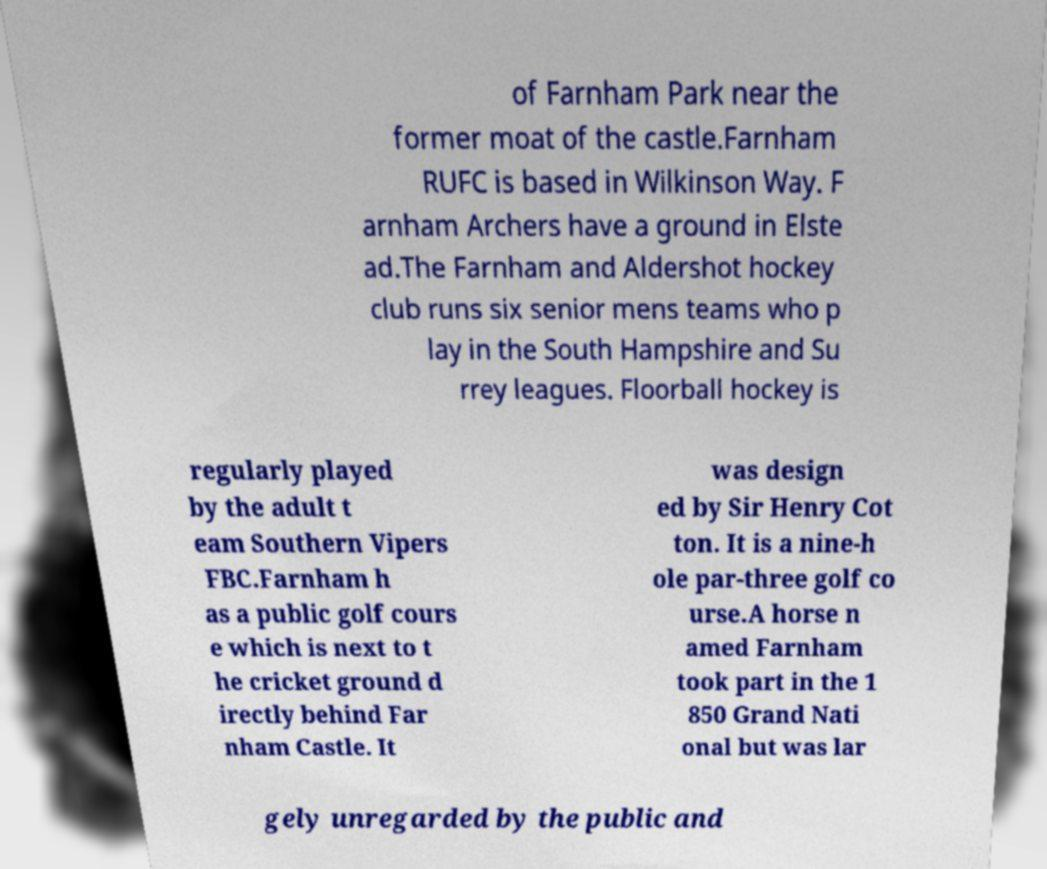Could you extract and type out the text from this image? of Farnham Park near the former moat of the castle.Farnham RUFC is based in Wilkinson Way. F arnham Archers have a ground in Elste ad.The Farnham and Aldershot hockey club runs six senior mens teams who p lay in the South Hampshire and Su rrey leagues. Floorball hockey is regularly played by the adult t eam Southern Vipers FBC.Farnham h as a public golf cours e which is next to t he cricket ground d irectly behind Far nham Castle. It was design ed by Sir Henry Cot ton. It is a nine-h ole par-three golf co urse.A horse n amed Farnham took part in the 1 850 Grand Nati onal but was lar gely unregarded by the public and 